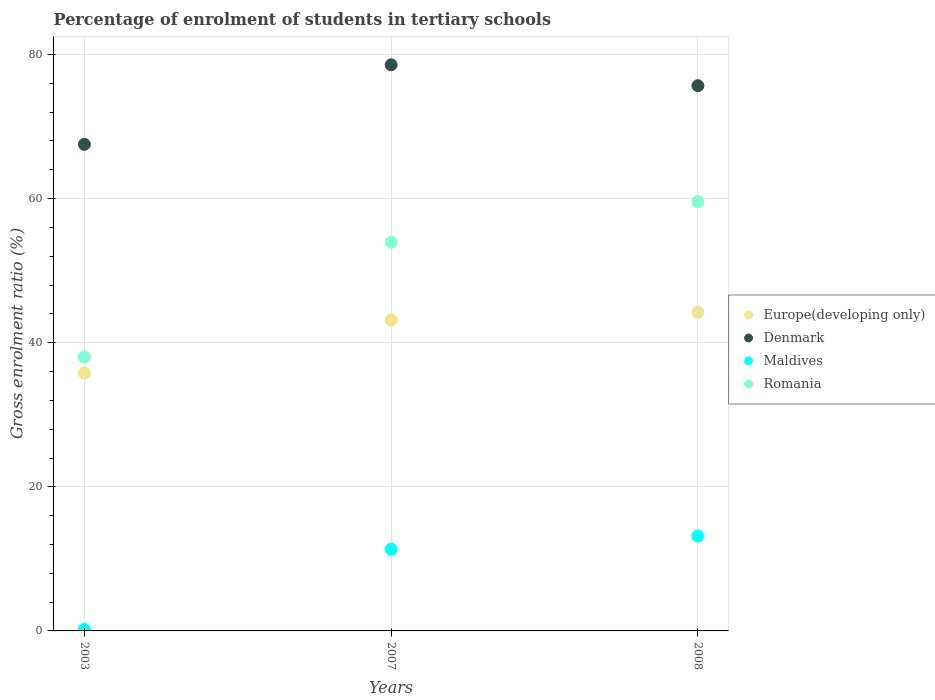Is the number of dotlines equal to the number of legend labels?
Your answer should be very brief. Yes. What is the percentage of students enrolled in tertiary schools in Denmark in 2008?
Offer a very short reply. 75.68. Across all years, what is the maximum percentage of students enrolled in tertiary schools in Europe(developing only)?
Make the answer very short. 44.21. Across all years, what is the minimum percentage of students enrolled in tertiary schools in Maldives?
Your answer should be very brief. 0.22. In which year was the percentage of students enrolled in tertiary schools in Maldives maximum?
Your answer should be compact. 2008. What is the total percentage of students enrolled in tertiary schools in Europe(developing only) in the graph?
Offer a very short reply. 123.14. What is the difference between the percentage of students enrolled in tertiary schools in Denmark in 2007 and that in 2008?
Keep it short and to the point. 2.9. What is the difference between the percentage of students enrolled in tertiary schools in Maldives in 2003 and the percentage of students enrolled in tertiary schools in Europe(developing only) in 2008?
Your answer should be compact. -43.99. What is the average percentage of students enrolled in tertiary schools in Denmark per year?
Offer a terse response. 73.93. In the year 2007, what is the difference between the percentage of students enrolled in tertiary schools in Romania and percentage of students enrolled in tertiary schools in Denmark?
Provide a short and direct response. -24.62. In how many years, is the percentage of students enrolled in tertiary schools in Maldives greater than 64 %?
Keep it short and to the point. 0. What is the ratio of the percentage of students enrolled in tertiary schools in Maldives in 2003 to that in 2007?
Your answer should be very brief. 0.02. What is the difference between the highest and the second highest percentage of students enrolled in tertiary schools in Romania?
Give a very brief answer. 5.64. What is the difference between the highest and the lowest percentage of students enrolled in tertiary schools in Romania?
Offer a terse response. 21.56. In how many years, is the percentage of students enrolled in tertiary schools in Europe(developing only) greater than the average percentage of students enrolled in tertiary schools in Europe(developing only) taken over all years?
Provide a short and direct response. 2. Is the sum of the percentage of students enrolled in tertiary schools in Denmark in 2003 and 2008 greater than the maximum percentage of students enrolled in tertiary schools in Europe(developing only) across all years?
Keep it short and to the point. Yes. Is it the case that in every year, the sum of the percentage of students enrolled in tertiary schools in Maldives and percentage of students enrolled in tertiary schools in Europe(developing only)  is greater than the sum of percentage of students enrolled in tertiary schools in Denmark and percentage of students enrolled in tertiary schools in Romania?
Your answer should be very brief. No. Is the percentage of students enrolled in tertiary schools in Romania strictly greater than the percentage of students enrolled in tertiary schools in Maldives over the years?
Keep it short and to the point. Yes. How many years are there in the graph?
Offer a terse response. 3. What is the difference between two consecutive major ticks on the Y-axis?
Provide a short and direct response. 20. Does the graph contain grids?
Offer a terse response. Yes. How many legend labels are there?
Provide a short and direct response. 4. How are the legend labels stacked?
Offer a very short reply. Vertical. What is the title of the graph?
Your answer should be compact. Percentage of enrolment of students in tertiary schools. Does "United Arab Emirates" appear as one of the legend labels in the graph?
Ensure brevity in your answer.  No. What is the label or title of the Y-axis?
Give a very brief answer. Gross enrolment ratio (%). What is the Gross enrolment ratio (%) in Europe(developing only) in 2003?
Provide a succinct answer. 35.78. What is the Gross enrolment ratio (%) of Denmark in 2003?
Keep it short and to the point. 67.54. What is the Gross enrolment ratio (%) of Maldives in 2003?
Offer a terse response. 0.22. What is the Gross enrolment ratio (%) of Romania in 2003?
Your answer should be compact. 38.03. What is the Gross enrolment ratio (%) in Europe(developing only) in 2007?
Offer a terse response. 43.14. What is the Gross enrolment ratio (%) in Denmark in 2007?
Your answer should be very brief. 78.58. What is the Gross enrolment ratio (%) of Maldives in 2007?
Your response must be concise. 11.34. What is the Gross enrolment ratio (%) of Romania in 2007?
Provide a short and direct response. 53.96. What is the Gross enrolment ratio (%) of Europe(developing only) in 2008?
Your answer should be very brief. 44.21. What is the Gross enrolment ratio (%) of Denmark in 2008?
Your answer should be very brief. 75.68. What is the Gross enrolment ratio (%) in Maldives in 2008?
Keep it short and to the point. 13.18. What is the Gross enrolment ratio (%) of Romania in 2008?
Provide a short and direct response. 59.59. Across all years, what is the maximum Gross enrolment ratio (%) of Europe(developing only)?
Provide a short and direct response. 44.21. Across all years, what is the maximum Gross enrolment ratio (%) in Denmark?
Make the answer very short. 78.58. Across all years, what is the maximum Gross enrolment ratio (%) of Maldives?
Provide a succinct answer. 13.18. Across all years, what is the maximum Gross enrolment ratio (%) in Romania?
Your answer should be very brief. 59.59. Across all years, what is the minimum Gross enrolment ratio (%) in Europe(developing only)?
Make the answer very short. 35.78. Across all years, what is the minimum Gross enrolment ratio (%) in Denmark?
Give a very brief answer. 67.54. Across all years, what is the minimum Gross enrolment ratio (%) of Maldives?
Offer a very short reply. 0.22. Across all years, what is the minimum Gross enrolment ratio (%) in Romania?
Ensure brevity in your answer.  38.03. What is the total Gross enrolment ratio (%) in Europe(developing only) in the graph?
Give a very brief answer. 123.14. What is the total Gross enrolment ratio (%) of Denmark in the graph?
Provide a succinct answer. 221.79. What is the total Gross enrolment ratio (%) of Maldives in the graph?
Give a very brief answer. 24.74. What is the total Gross enrolment ratio (%) in Romania in the graph?
Keep it short and to the point. 151.58. What is the difference between the Gross enrolment ratio (%) of Europe(developing only) in 2003 and that in 2007?
Your answer should be compact. -7.37. What is the difference between the Gross enrolment ratio (%) in Denmark in 2003 and that in 2007?
Offer a terse response. -11.04. What is the difference between the Gross enrolment ratio (%) of Maldives in 2003 and that in 2007?
Provide a short and direct response. -11.11. What is the difference between the Gross enrolment ratio (%) in Romania in 2003 and that in 2007?
Ensure brevity in your answer.  -15.92. What is the difference between the Gross enrolment ratio (%) of Europe(developing only) in 2003 and that in 2008?
Your answer should be very brief. -8.44. What is the difference between the Gross enrolment ratio (%) in Denmark in 2003 and that in 2008?
Provide a short and direct response. -8.14. What is the difference between the Gross enrolment ratio (%) in Maldives in 2003 and that in 2008?
Offer a terse response. -12.96. What is the difference between the Gross enrolment ratio (%) in Romania in 2003 and that in 2008?
Make the answer very short. -21.56. What is the difference between the Gross enrolment ratio (%) in Europe(developing only) in 2007 and that in 2008?
Your answer should be compact. -1.07. What is the difference between the Gross enrolment ratio (%) in Denmark in 2007 and that in 2008?
Make the answer very short. 2.9. What is the difference between the Gross enrolment ratio (%) in Maldives in 2007 and that in 2008?
Your answer should be very brief. -1.85. What is the difference between the Gross enrolment ratio (%) of Romania in 2007 and that in 2008?
Make the answer very short. -5.64. What is the difference between the Gross enrolment ratio (%) of Europe(developing only) in 2003 and the Gross enrolment ratio (%) of Denmark in 2007?
Ensure brevity in your answer.  -42.8. What is the difference between the Gross enrolment ratio (%) of Europe(developing only) in 2003 and the Gross enrolment ratio (%) of Maldives in 2007?
Keep it short and to the point. 24.44. What is the difference between the Gross enrolment ratio (%) of Europe(developing only) in 2003 and the Gross enrolment ratio (%) of Romania in 2007?
Provide a succinct answer. -18.18. What is the difference between the Gross enrolment ratio (%) in Denmark in 2003 and the Gross enrolment ratio (%) in Maldives in 2007?
Ensure brevity in your answer.  56.2. What is the difference between the Gross enrolment ratio (%) of Denmark in 2003 and the Gross enrolment ratio (%) of Romania in 2007?
Your answer should be very brief. 13.58. What is the difference between the Gross enrolment ratio (%) of Maldives in 2003 and the Gross enrolment ratio (%) of Romania in 2007?
Your answer should be very brief. -53.73. What is the difference between the Gross enrolment ratio (%) in Europe(developing only) in 2003 and the Gross enrolment ratio (%) in Denmark in 2008?
Provide a succinct answer. -39.9. What is the difference between the Gross enrolment ratio (%) in Europe(developing only) in 2003 and the Gross enrolment ratio (%) in Maldives in 2008?
Your answer should be compact. 22.6. What is the difference between the Gross enrolment ratio (%) in Europe(developing only) in 2003 and the Gross enrolment ratio (%) in Romania in 2008?
Provide a succinct answer. -23.81. What is the difference between the Gross enrolment ratio (%) of Denmark in 2003 and the Gross enrolment ratio (%) of Maldives in 2008?
Offer a terse response. 54.36. What is the difference between the Gross enrolment ratio (%) of Denmark in 2003 and the Gross enrolment ratio (%) of Romania in 2008?
Keep it short and to the point. 7.95. What is the difference between the Gross enrolment ratio (%) of Maldives in 2003 and the Gross enrolment ratio (%) of Romania in 2008?
Make the answer very short. -59.37. What is the difference between the Gross enrolment ratio (%) of Europe(developing only) in 2007 and the Gross enrolment ratio (%) of Denmark in 2008?
Keep it short and to the point. -32.53. What is the difference between the Gross enrolment ratio (%) of Europe(developing only) in 2007 and the Gross enrolment ratio (%) of Maldives in 2008?
Your answer should be very brief. 29.96. What is the difference between the Gross enrolment ratio (%) of Europe(developing only) in 2007 and the Gross enrolment ratio (%) of Romania in 2008?
Your answer should be compact. -16.45. What is the difference between the Gross enrolment ratio (%) of Denmark in 2007 and the Gross enrolment ratio (%) of Maldives in 2008?
Give a very brief answer. 65.39. What is the difference between the Gross enrolment ratio (%) of Denmark in 2007 and the Gross enrolment ratio (%) of Romania in 2008?
Provide a short and direct response. 18.98. What is the difference between the Gross enrolment ratio (%) of Maldives in 2007 and the Gross enrolment ratio (%) of Romania in 2008?
Your response must be concise. -48.26. What is the average Gross enrolment ratio (%) in Europe(developing only) per year?
Ensure brevity in your answer.  41.05. What is the average Gross enrolment ratio (%) in Denmark per year?
Your answer should be compact. 73.93. What is the average Gross enrolment ratio (%) of Maldives per year?
Make the answer very short. 8.25. What is the average Gross enrolment ratio (%) in Romania per year?
Offer a very short reply. 50.53. In the year 2003, what is the difference between the Gross enrolment ratio (%) in Europe(developing only) and Gross enrolment ratio (%) in Denmark?
Keep it short and to the point. -31.76. In the year 2003, what is the difference between the Gross enrolment ratio (%) of Europe(developing only) and Gross enrolment ratio (%) of Maldives?
Your answer should be very brief. 35.56. In the year 2003, what is the difference between the Gross enrolment ratio (%) in Europe(developing only) and Gross enrolment ratio (%) in Romania?
Make the answer very short. -2.26. In the year 2003, what is the difference between the Gross enrolment ratio (%) in Denmark and Gross enrolment ratio (%) in Maldives?
Ensure brevity in your answer.  67.32. In the year 2003, what is the difference between the Gross enrolment ratio (%) of Denmark and Gross enrolment ratio (%) of Romania?
Keep it short and to the point. 29.5. In the year 2003, what is the difference between the Gross enrolment ratio (%) in Maldives and Gross enrolment ratio (%) in Romania?
Offer a very short reply. -37.81. In the year 2007, what is the difference between the Gross enrolment ratio (%) in Europe(developing only) and Gross enrolment ratio (%) in Denmark?
Make the answer very short. -35.43. In the year 2007, what is the difference between the Gross enrolment ratio (%) in Europe(developing only) and Gross enrolment ratio (%) in Maldives?
Offer a terse response. 31.81. In the year 2007, what is the difference between the Gross enrolment ratio (%) of Europe(developing only) and Gross enrolment ratio (%) of Romania?
Your response must be concise. -10.81. In the year 2007, what is the difference between the Gross enrolment ratio (%) in Denmark and Gross enrolment ratio (%) in Maldives?
Provide a succinct answer. 67.24. In the year 2007, what is the difference between the Gross enrolment ratio (%) of Denmark and Gross enrolment ratio (%) of Romania?
Make the answer very short. 24.62. In the year 2007, what is the difference between the Gross enrolment ratio (%) of Maldives and Gross enrolment ratio (%) of Romania?
Ensure brevity in your answer.  -42.62. In the year 2008, what is the difference between the Gross enrolment ratio (%) in Europe(developing only) and Gross enrolment ratio (%) in Denmark?
Your answer should be compact. -31.46. In the year 2008, what is the difference between the Gross enrolment ratio (%) in Europe(developing only) and Gross enrolment ratio (%) in Maldives?
Provide a succinct answer. 31.03. In the year 2008, what is the difference between the Gross enrolment ratio (%) of Europe(developing only) and Gross enrolment ratio (%) of Romania?
Keep it short and to the point. -15.38. In the year 2008, what is the difference between the Gross enrolment ratio (%) in Denmark and Gross enrolment ratio (%) in Maldives?
Your answer should be very brief. 62.49. In the year 2008, what is the difference between the Gross enrolment ratio (%) in Denmark and Gross enrolment ratio (%) in Romania?
Ensure brevity in your answer.  16.08. In the year 2008, what is the difference between the Gross enrolment ratio (%) of Maldives and Gross enrolment ratio (%) of Romania?
Your answer should be compact. -46.41. What is the ratio of the Gross enrolment ratio (%) of Europe(developing only) in 2003 to that in 2007?
Give a very brief answer. 0.83. What is the ratio of the Gross enrolment ratio (%) of Denmark in 2003 to that in 2007?
Your answer should be very brief. 0.86. What is the ratio of the Gross enrolment ratio (%) of Maldives in 2003 to that in 2007?
Make the answer very short. 0.02. What is the ratio of the Gross enrolment ratio (%) in Romania in 2003 to that in 2007?
Keep it short and to the point. 0.7. What is the ratio of the Gross enrolment ratio (%) in Europe(developing only) in 2003 to that in 2008?
Give a very brief answer. 0.81. What is the ratio of the Gross enrolment ratio (%) in Denmark in 2003 to that in 2008?
Your answer should be very brief. 0.89. What is the ratio of the Gross enrolment ratio (%) of Maldives in 2003 to that in 2008?
Give a very brief answer. 0.02. What is the ratio of the Gross enrolment ratio (%) in Romania in 2003 to that in 2008?
Your answer should be very brief. 0.64. What is the ratio of the Gross enrolment ratio (%) of Europe(developing only) in 2007 to that in 2008?
Ensure brevity in your answer.  0.98. What is the ratio of the Gross enrolment ratio (%) of Denmark in 2007 to that in 2008?
Offer a very short reply. 1.04. What is the ratio of the Gross enrolment ratio (%) in Maldives in 2007 to that in 2008?
Provide a succinct answer. 0.86. What is the ratio of the Gross enrolment ratio (%) in Romania in 2007 to that in 2008?
Your answer should be very brief. 0.91. What is the difference between the highest and the second highest Gross enrolment ratio (%) in Europe(developing only)?
Provide a succinct answer. 1.07. What is the difference between the highest and the second highest Gross enrolment ratio (%) of Denmark?
Your response must be concise. 2.9. What is the difference between the highest and the second highest Gross enrolment ratio (%) in Maldives?
Your response must be concise. 1.85. What is the difference between the highest and the second highest Gross enrolment ratio (%) in Romania?
Your answer should be very brief. 5.64. What is the difference between the highest and the lowest Gross enrolment ratio (%) of Europe(developing only)?
Keep it short and to the point. 8.44. What is the difference between the highest and the lowest Gross enrolment ratio (%) of Denmark?
Make the answer very short. 11.04. What is the difference between the highest and the lowest Gross enrolment ratio (%) of Maldives?
Keep it short and to the point. 12.96. What is the difference between the highest and the lowest Gross enrolment ratio (%) in Romania?
Offer a terse response. 21.56. 